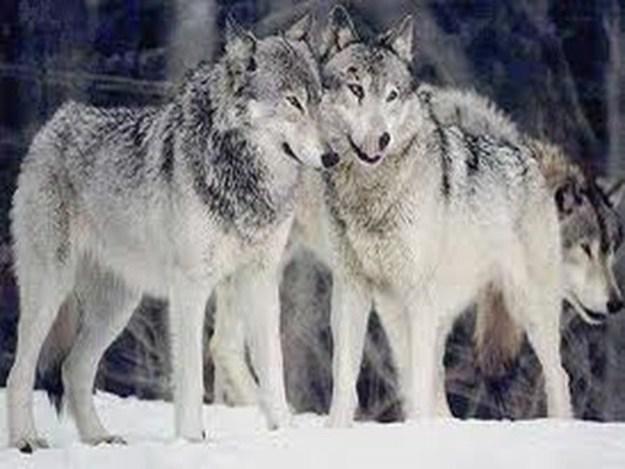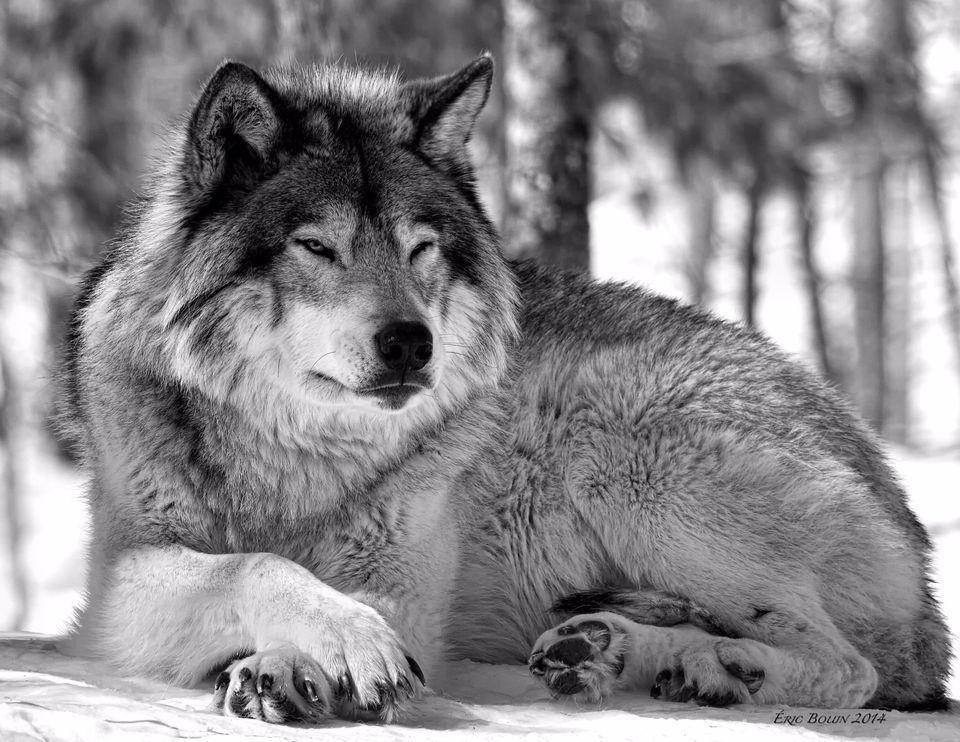The first image is the image on the left, the second image is the image on the right. For the images displayed, is the sentence "The left image contains at least two wolves." factually correct? Answer yes or no. Yes. The first image is the image on the left, the second image is the image on the right. For the images shown, is this caption "The right image features one wolf reclining with its body turned leftward and its gaze slightly rightward, and the left image contains at least three wolves." true? Answer yes or no. Yes. 